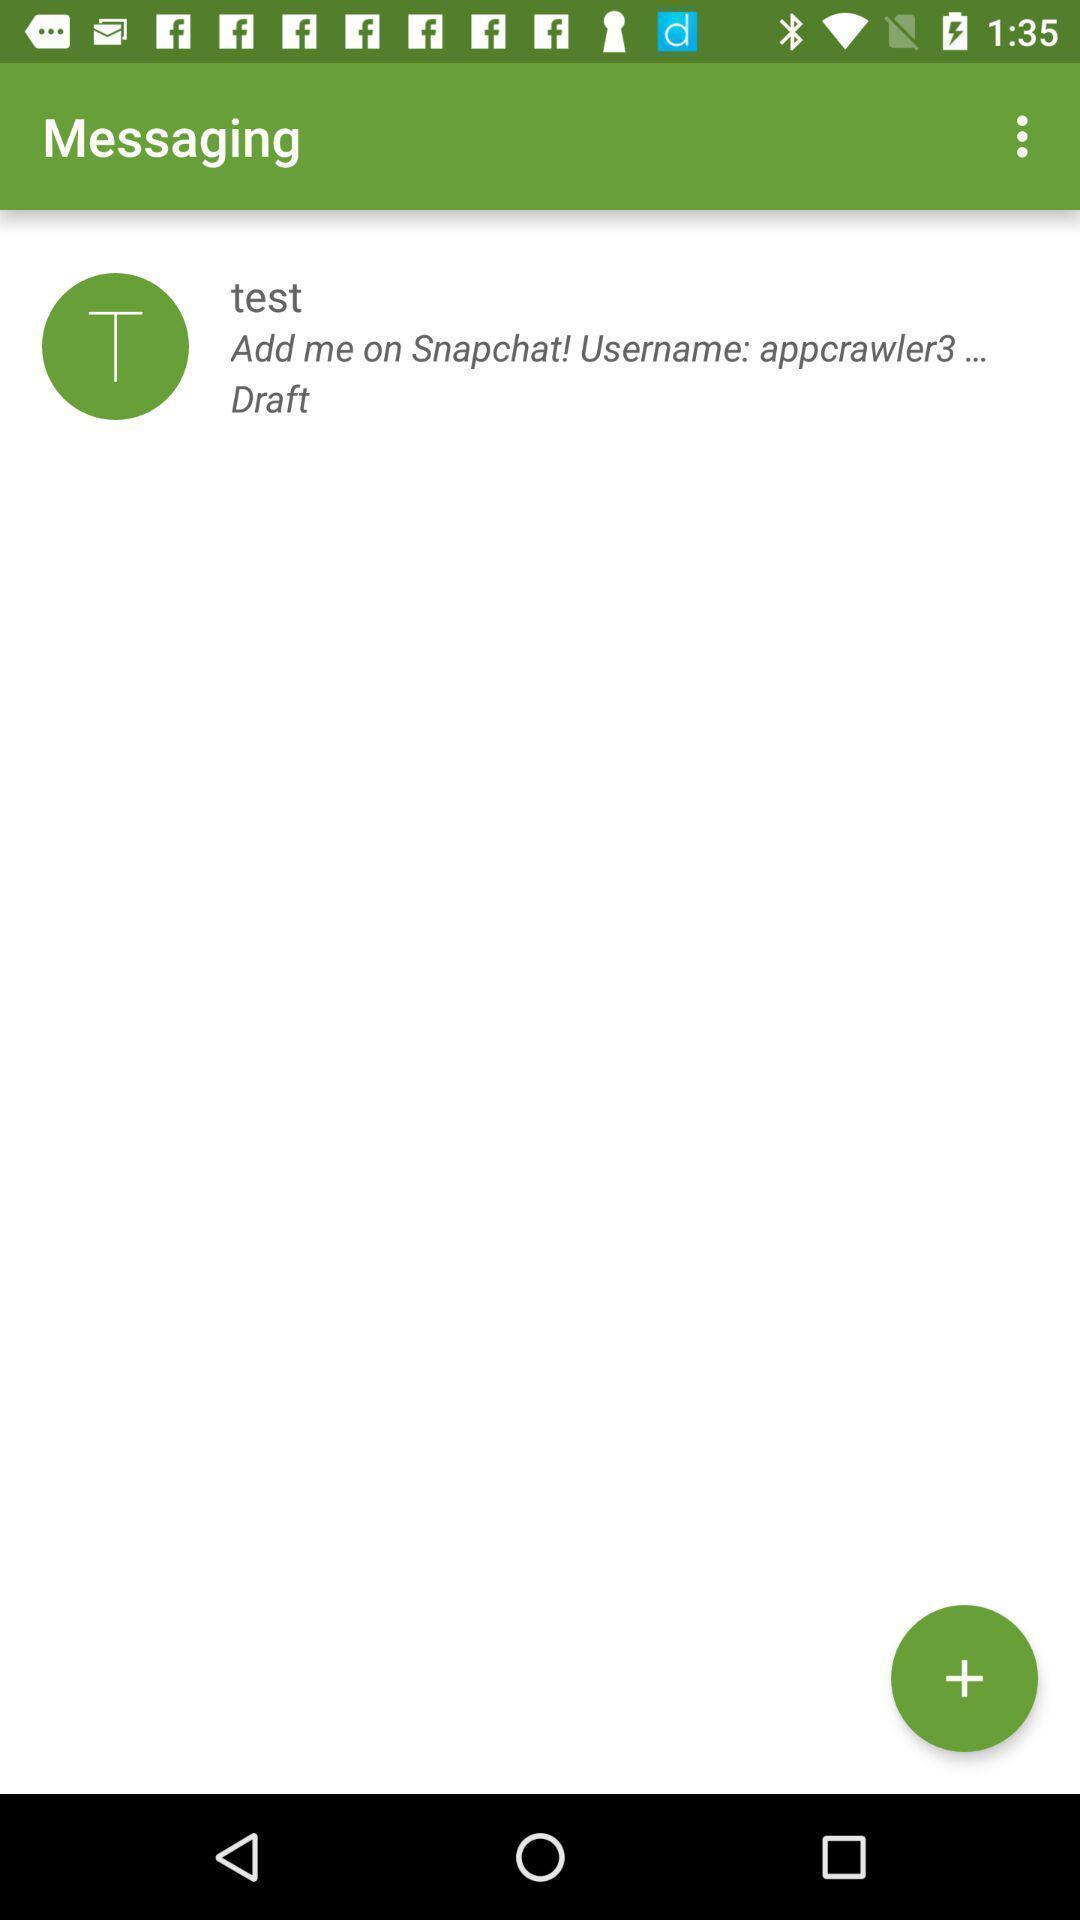Provide a detailed account of this screenshot. Screen displaying the messaging page. 